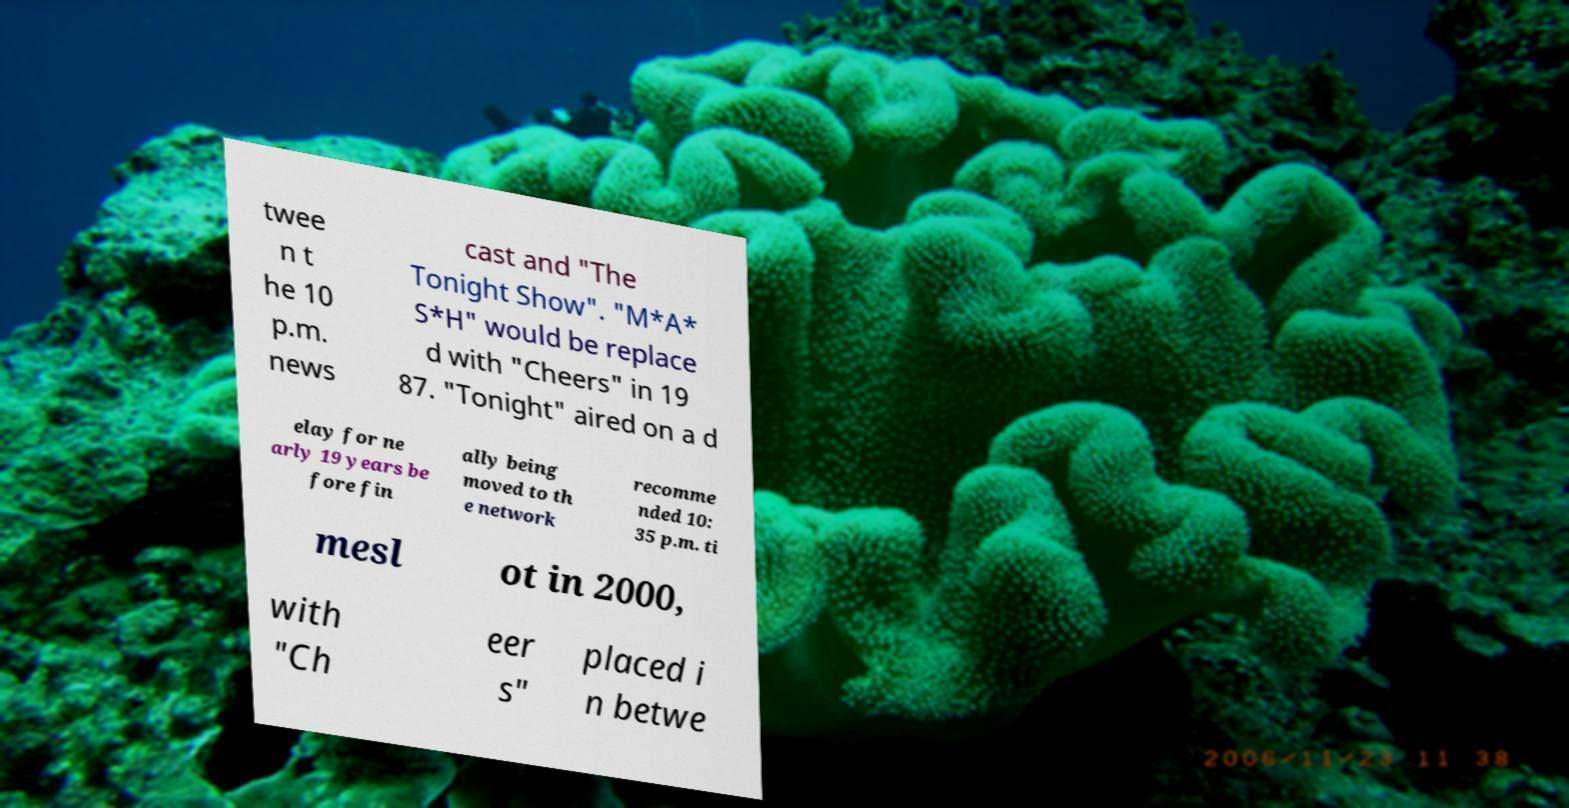Can you read and provide the text displayed in the image?This photo seems to have some interesting text. Can you extract and type it out for me? twee n t he 10 p.m. news cast and "The Tonight Show". "M*A* S*H" would be replace d with "Cheers" in 19 87. "Tonight" aired on a d elay for ne arly 19 years be fore fin ally being moved to th e network recomme nded 10: 35 p.m. ti mesl ot in 2000, with "Ch eer s" placed i n betwe 